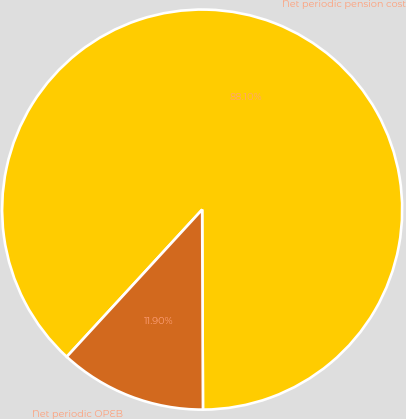Convert chart to OTSL. <chart><loc_0><loc_0><loc_500><loc_500><pie_chart><fcel>Net periodic pension cost<fcel>Net periodic OPEB<nl><fcel>88.1%<fcel>11.9%<nl></chart> 